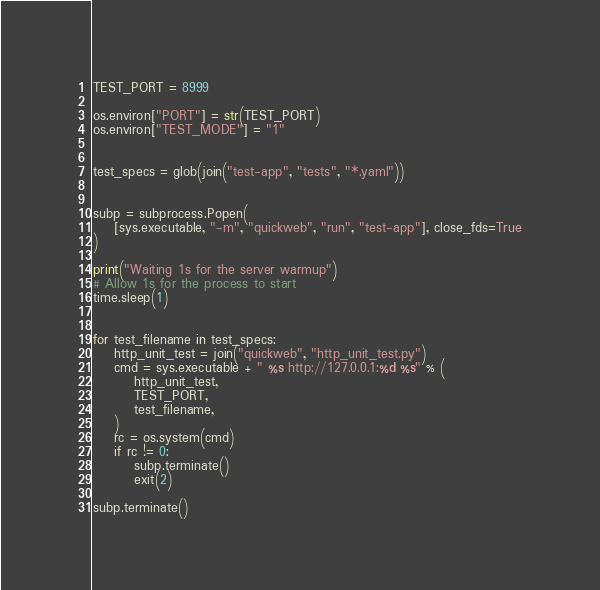<code> <loc_0><loc_0><loc_500><loc_500><_Python_>
TEST_PORT = 8999

os.environ["PORT"] = str(TEST_PORT)
os.environ["TEST_MODE"] = "1"


test_specs = glob(join("test-app", "tests", "*.yaml"))


subp = subprocess.Popen(
    [sys.executable, "-m", "quickweb", "run", "test-app"], close_fds=True
)

print("Waiting 1s for the server warmup")
# Allow 1s for the process to start
time.sleep(1)


for test_filename in test_specs:
    http_unit_test = join("quickweb", "http_unit_test.py")
    cmd = sys.executable + " %s http://127.0.0.1:%d %s" % (
        http_unit_test,
        TEST_PORT,
        test_filename,
    )
    rc = os.system(cmd)
    if rc != 0:
        subp.terminate()
        exit(2)

subp.terminate()
</code> 